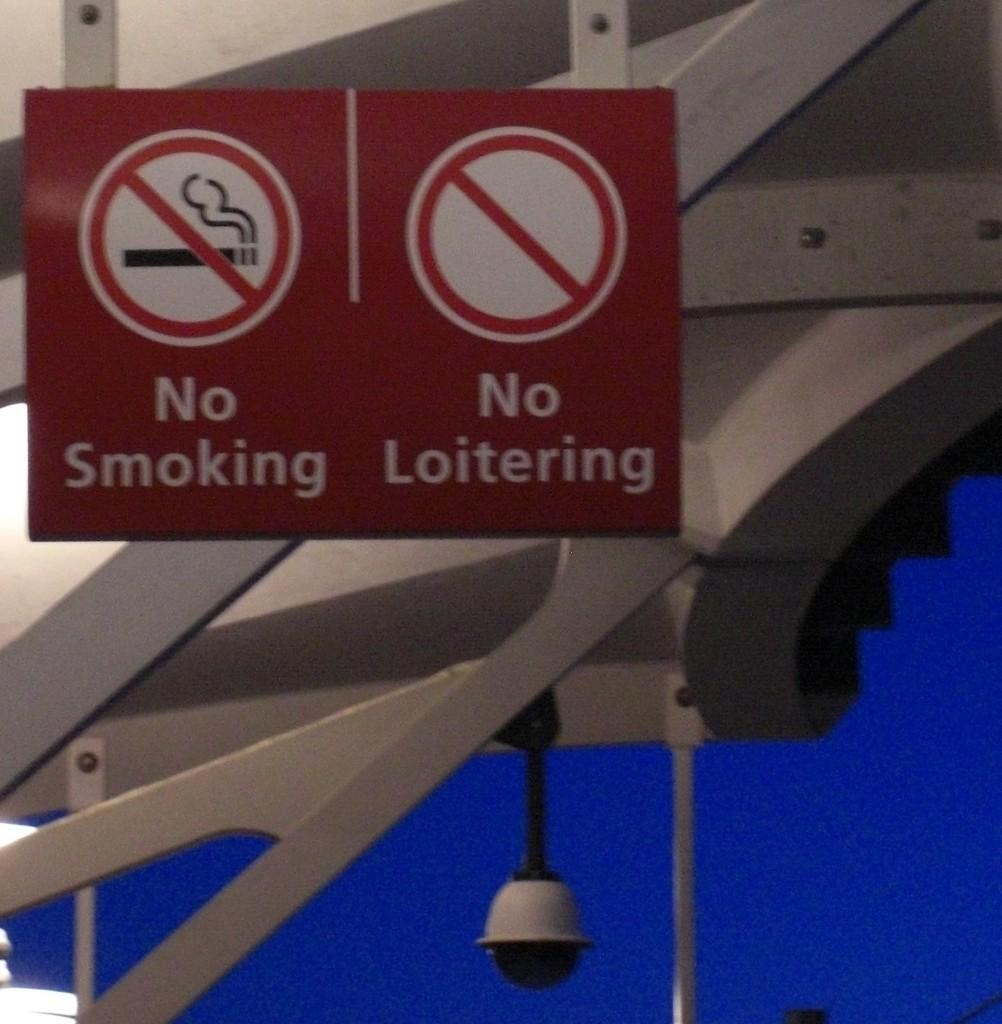<image>
Render a clear and concise summary of the photo. The location specifies No Smoking and No Loitering. 